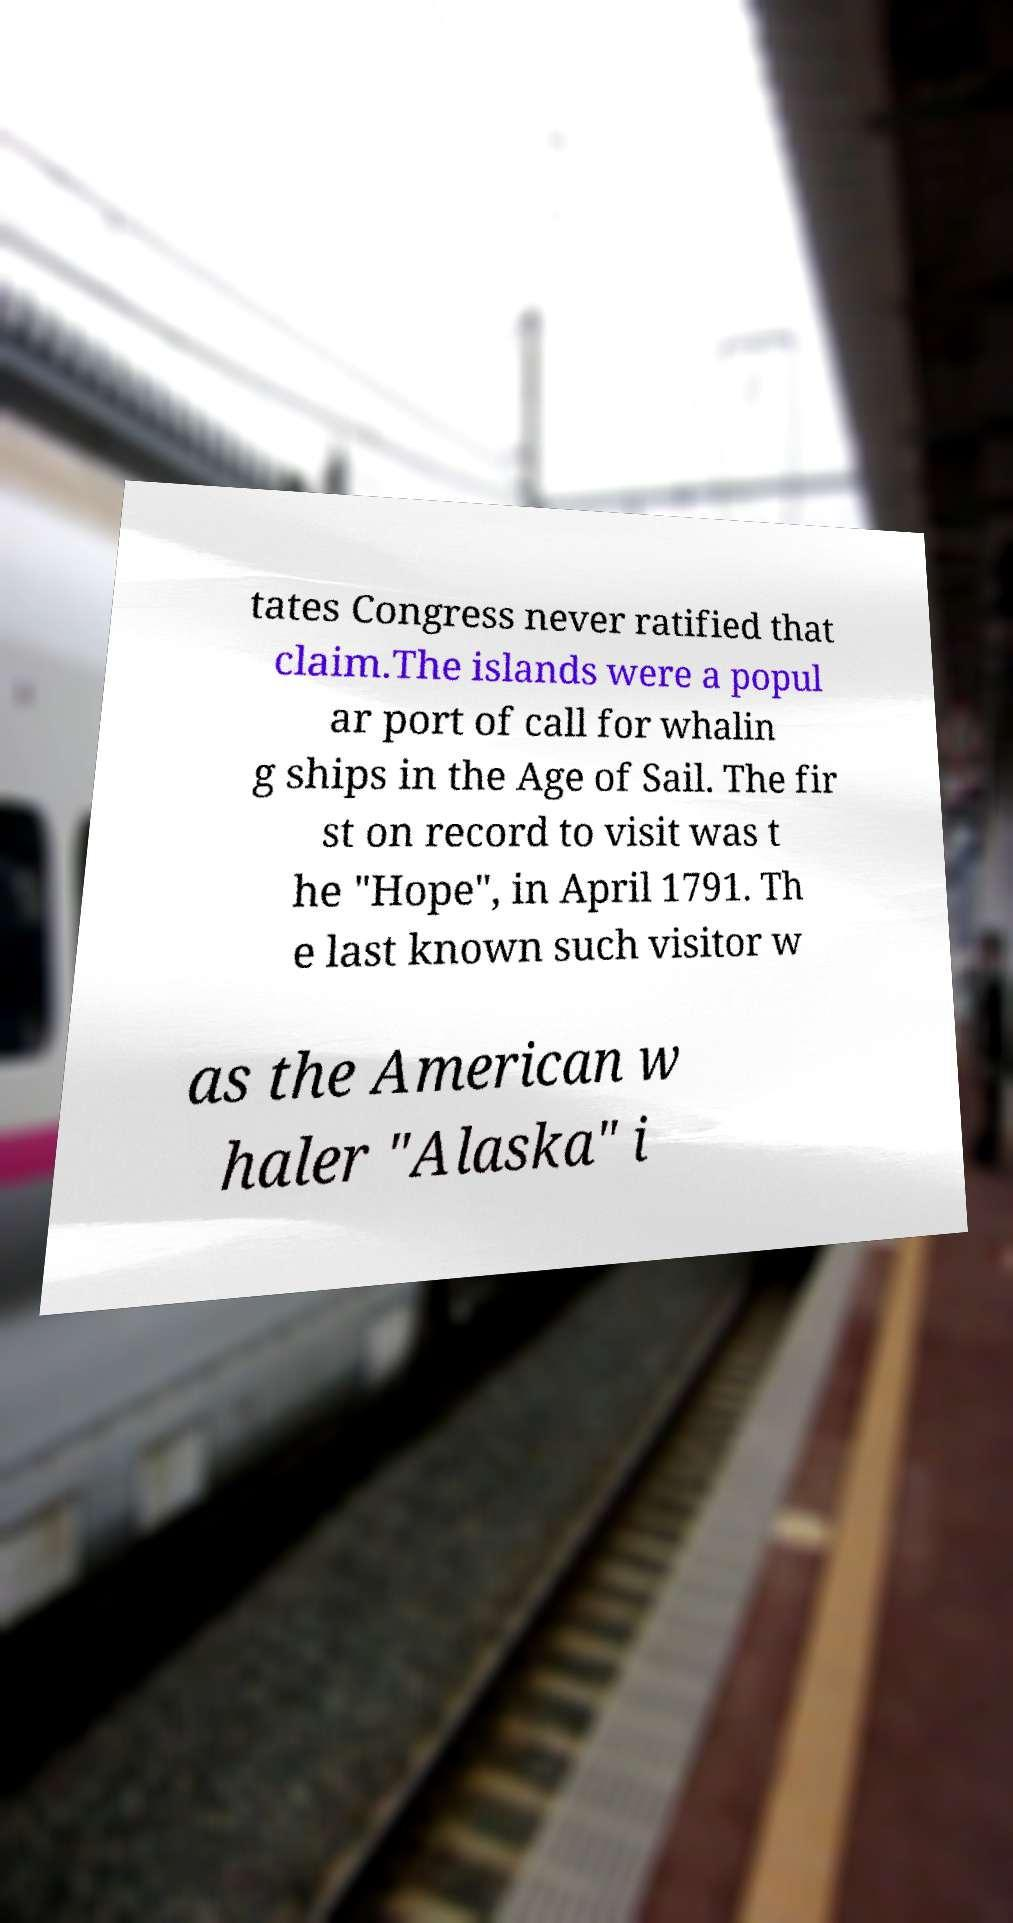For documentation purposes, I need the text within this image transcribed. Could you provide that? tates Congress never ratified that claim.The islands were a popul ar port of call for whalin g ships in the Age of Sail. The fir st on record to visit was t he "Hope", in April 1791. Th e last known such visitor w as the American w haler "Alaska" i 